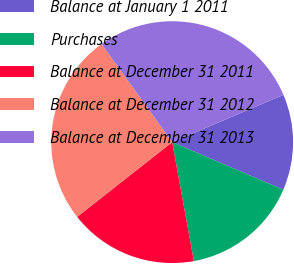<chart> <loc_0><loc_0><loc_500><loc_500><pie_chart><fcel>Balance at January 1 2011<fcel>Purchases<fcel>Balance at December 31 2011<fcel>Balance at December 31 2012<fcel>Balance at December 31 2013<nl><fcel>12.84%<fcel>15.69%<fcel>17.26%<fcel>25.68%<fcel>28.53%<nl></chart> 